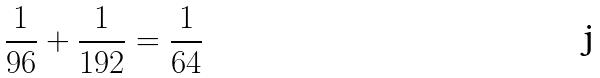<formula> <loc_0><loc_0><loc_500><loc_500>\frac { 1 } { 9 6 } + \frac { 1 } { 1 9 2 } = \frac { 1 } { 6 4 }</formula> 